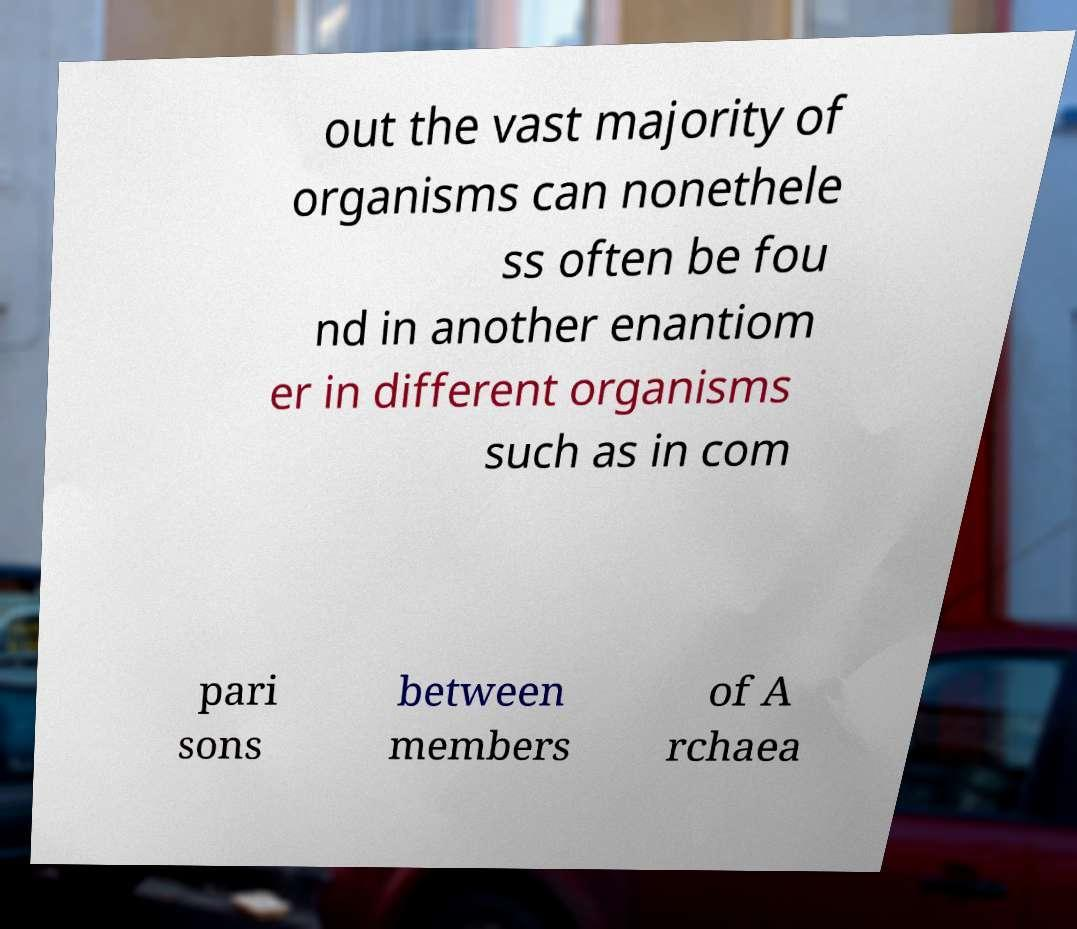Please read and relay the text visible in this image. What does it say? out the vast majority of organisms can nonethele ss often be fou nd in another enantiom er in different organisms such as in com pari sons between members of A rchaea 